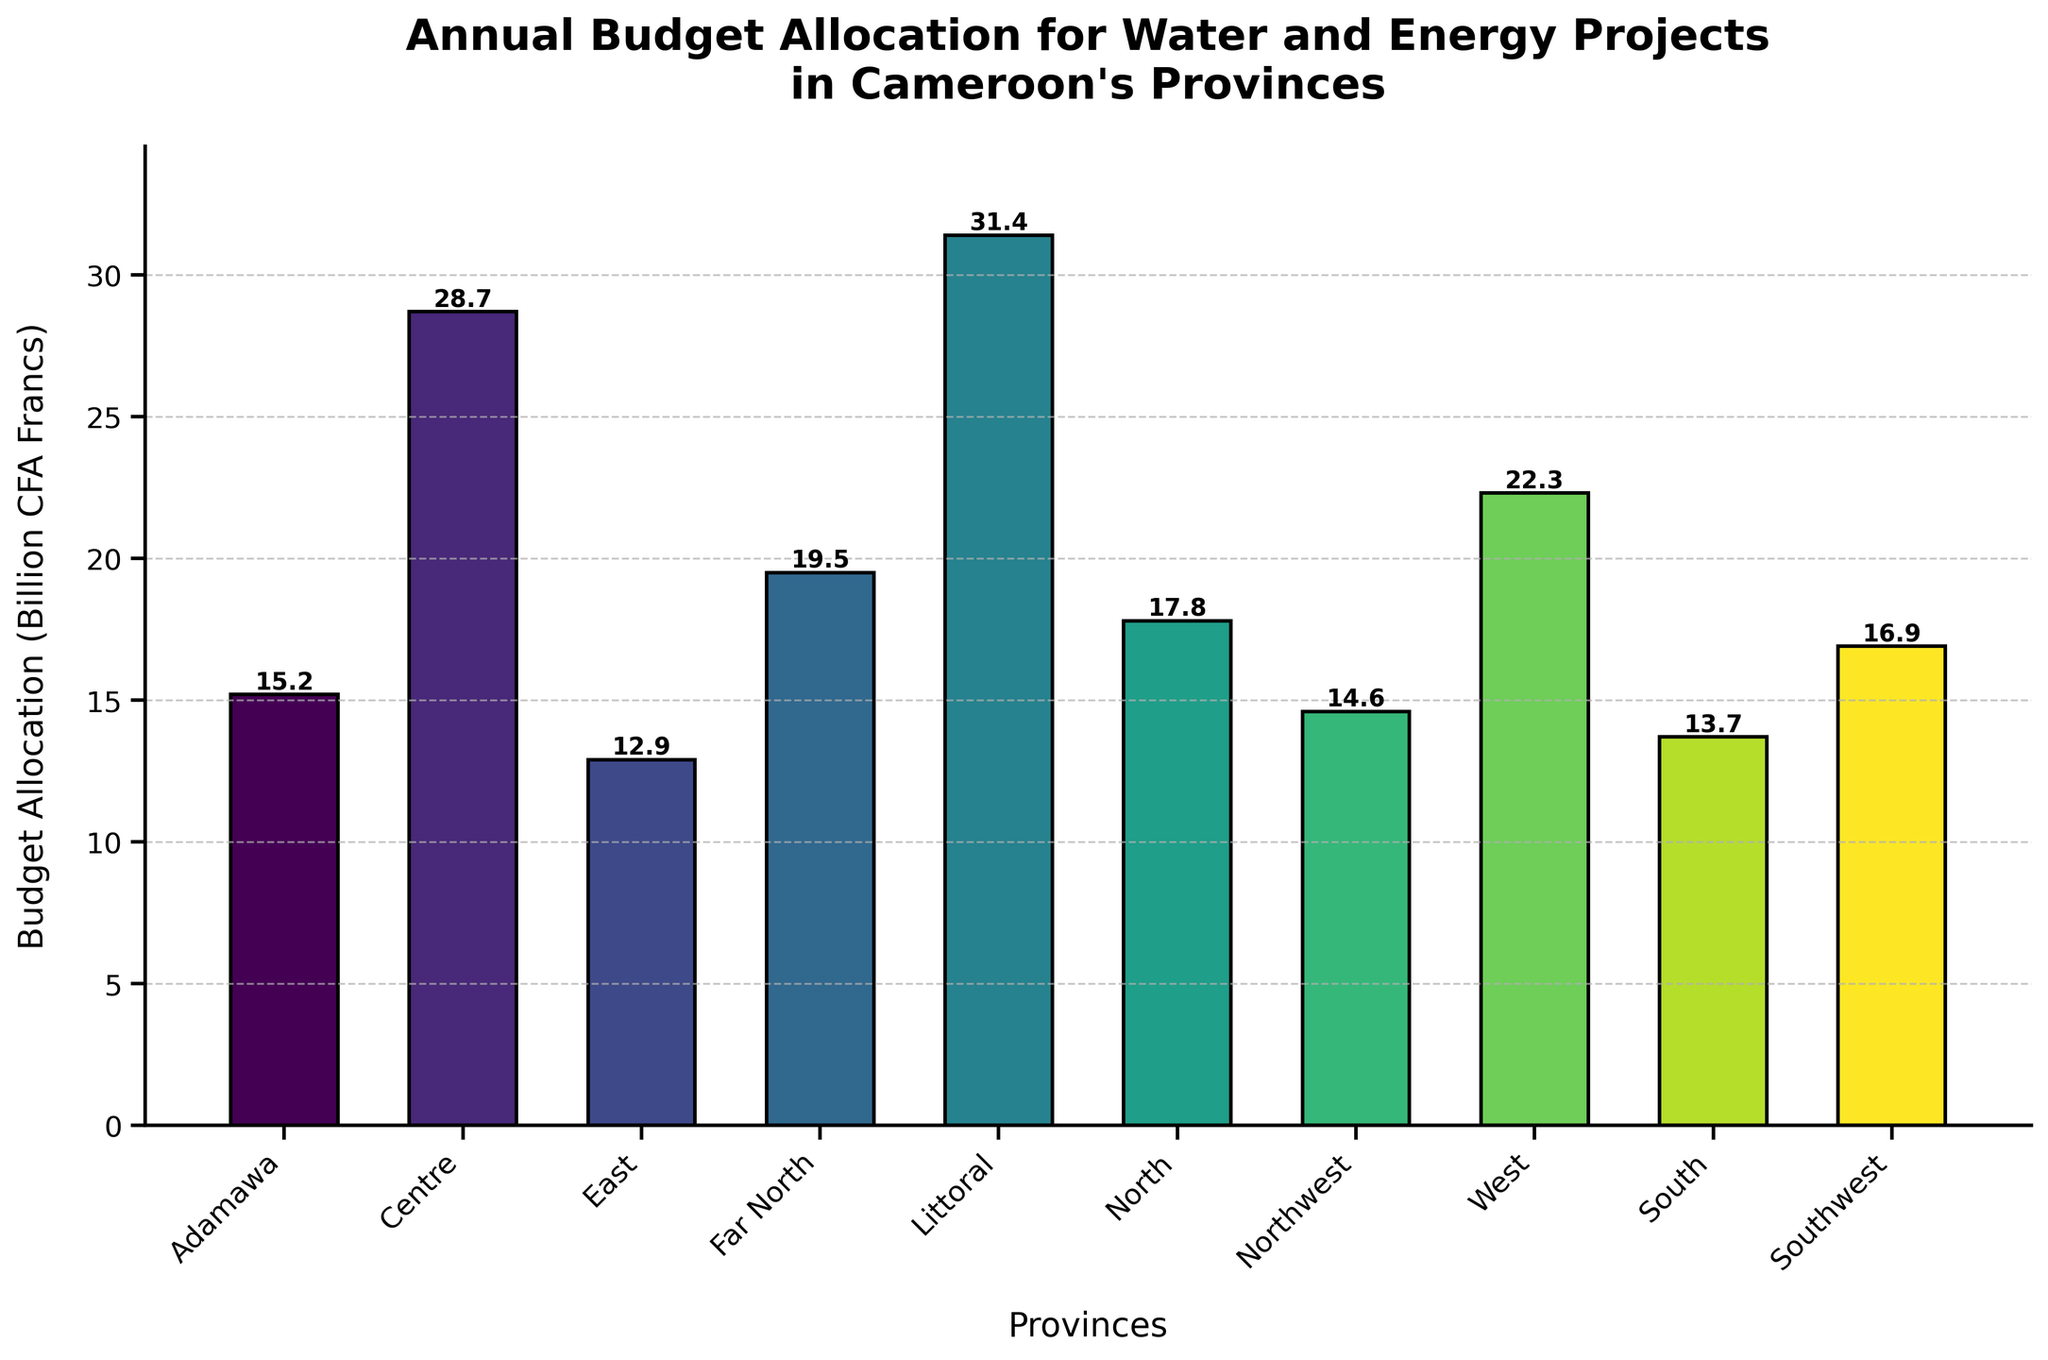Which province has the highest budget allocation? The height of the bar for Littoral province is the tallest, indicating the highest budget allocation
Answer: Littoral What's the sum of the budget allocations for the Centre and Far North provinces? The budget allocation for Centre is 28.7 billion CFA Francs, and for Far North, it is 19.5 billion CFA Francs. Summing them gives 28.7 + 19.5 = 48.2 billion CFA Francs
Answer: 48.2 billion CFA Francs Which provinces have a budget allocation greater than 20 billion CFA Francs? The bars for Centre (28.7), Littoral (31.4), and West (22.3) provinces exceed the 20 billion CFA Francs mark
Answer: Centre, Littoral, West How much more is the budget allocation for North compared to East? The budget allocation for North is 17.8 billion CFA Francs, and for East, it is 12.9 billion CFA Francs. The difference is 17.8 - 12.9 = 4.9 billion CFA Francs
Answer: 4.9 billion CFA Francs Which province has the lowest budget allocation? The bar for East province is the shortest, indicating the lowest budget allocation
Answer: East What is the average budget allocation across all provinces? Summing up the budget allocations (15.2 + 28.7 + 12.9 + 19.5 + 31.4 + 17.8 + 14.6 + 22.3 + 13.7 + 16.9) and dividing by 10 gives (193 / 10) = 19.3 billion CFA Francs
Answer: 19.3 billion CFA Francs Is the budget allocation for Southwest higher than North? The budget allocation for Southwest is 16.9 billion CFA Francs, and for North, it is 17.8 billion CFA Francs. So, Southwest is lower than North
Answer: No Rank the top three provinces in terms of budget allocation from highest to lowest. The highest is Littoral (31.4), followed by Centre (28.7), and West (22.3)
Answer: Littoral, Centre, West What is the difference between the highest and the lowest budget allocations? The highest budget allocation is for Littoral (31.4 billion CFA Francs) and the lowest is for East (12.9 billion CFA Francs). The difference is 31.4 - 12.9 = 18.5 billion CFA Francs
Answer: 18.5 billion CFA Francs 